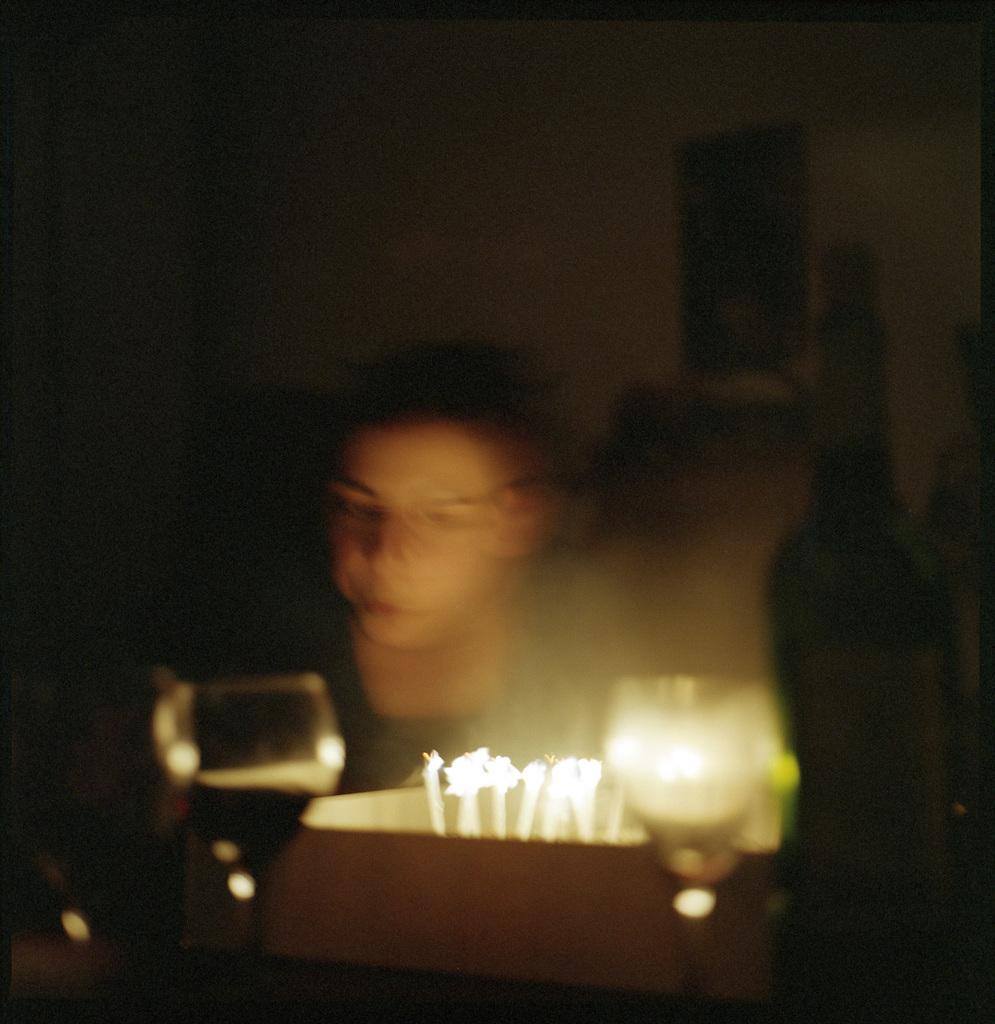Who or what is present in the image? There is a person in the image. What is the person likely celebrating or commemorating? The presence of a cake, glasses, and candles with flames suggests a celebration or birthday. What objects are visible in the image besides the person? There is a cake, glasses, and candles with flames visible in the image. What can be seen in the background of the image? There is a frame attached to the wall in the background of the image. How many shoes are visible in the image? There are no shoes visible in the image. What is the person's level of wealth based on the image? The image does not provide any information about the person's wealth. How long does it take for the candles to burn down in the image? The image does not show the candles burning down, so it is impossible to determine how long it takes for them to burn down. 